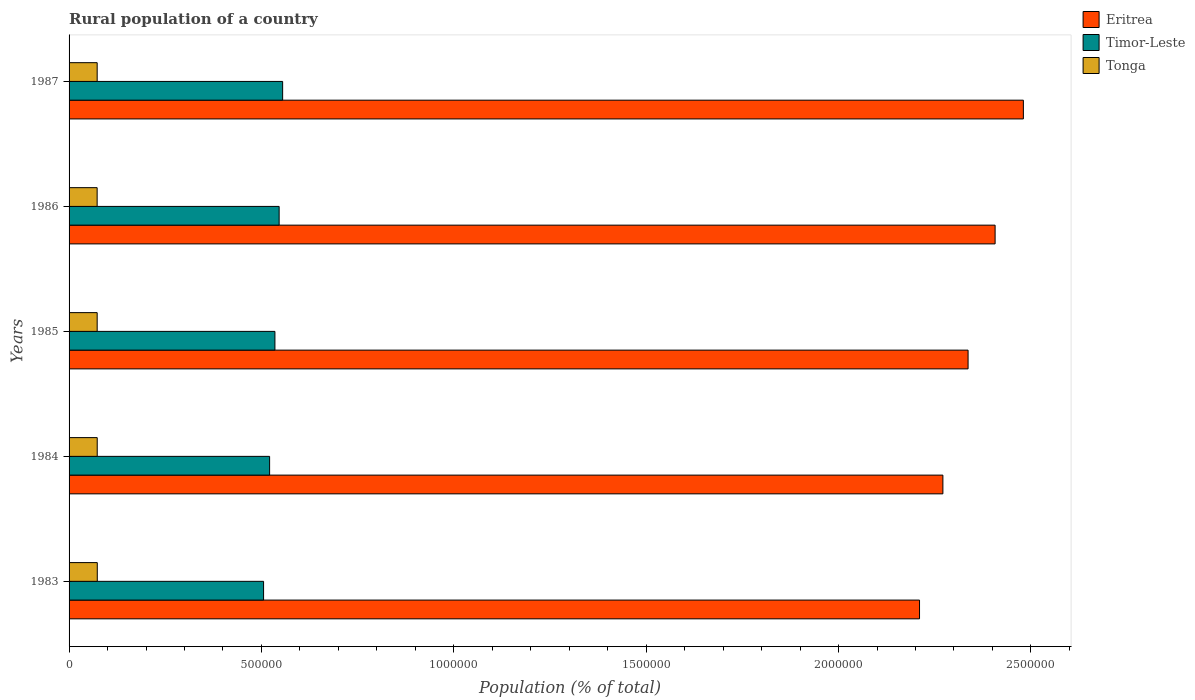How many groups of bars are there?
Your answer should be very brief. 5. How many bars are there on the 5th tick from the bottom?
Your answer should be very brief. 3. What is the rural population in Eritrea in 1987?
Offer a very short reply. 2.48e+06. Across all years, what is the maximum rural population in Timor-Leste?
Your response must be concise. 5.55e+05. Across all years, what is the minimum rural population in Tonga?
Offer a terse response. 7.30e+04. In which year was the rural population in Tonga maximum?
Make the answer very short. 1983. What is the total rural population in Eritrea in the graph?
Offer a very short reply. 1.17e+07. What is the difference between the rural population in Eritrea in 1983 and that in 1984?
Provide a succinct answer. -6.07e+04. What is the difference between the rural population in Tonga in 1986 and the rural population in Timor-Leste in 1984?
Your answer should be very brief. -4.48e+05. What is the average rural population in Tonga per year?
Provide a short and direct response. 7.31e+04. In the year 1984, what is the difference between the rural population in Timor-Leste and rural population in Tonga?
Your answer should be very brief. 4.48e+05. What is the ratio of the rural population in Eritrea in 1983 to that in 1987?
Keep it short and to the point. 0.89. What is the difference between the highest and the second highest rural population in Timor-Leste?
Your answer should be compact. 9097. What is the difference between the highest and the lowest rural population in Eritrea?
Your response must be concise. 2.70e+05. In how many years, is the rural population in Eritrea greater than the average rural population in Eritrea taken over all years?
Provide a short and direct response. 2. What does the 1st bar from the top in 1985 represents?
Provide a succinct answer. Tonga. What does the 3rd bar from the bottom in 1983 represents?
Provide a short and direct response. Tonga. Is it the case that in every year, the sum of the rural population in Tonga and rural population in Eritrea is greater than the rural population in Timor-Leste?
Provide a succinct answer. Yes. How many years are there in the graph?
Offer a very short reply. 5. Are the values on the major ticks of X-axis written in scientific E-notation?
Provide a short and direct response. No. Does the graph contain grids?
Provide a succinct answer. No. How many legend labels are there?
Provide a succinct answer. 3. What is the title of the graph?
Your answer should be compact. Rural population of a country. What is the label or title of the X-axis?
Provide a short and direct response. Population (% of total). What is the Population (% of total) in Eritrea in 1983?
Offer a terse response. 2.21e+06. What is the Population (% of total) of Timor-Leste in 1983?
Provide a succinct answer. 5.06e+05. What is the Population (% of total) of Tonga in 1983?
Keep it short and to the point. 7.33e+04. What is the Population (% of total) of Eritrea in 1984?
Provide a short and direct response. 2.27e+06. What is the Population (% of total) of Timor-Leste in 1984?
Offer a very short reply. 5.21e+05. What is the Population (% of total) in Tonga in 1984?
Your answer should be very brief. 7.32e+04. What is the Population (% of total) in Eritrea in 1985?
Ensure brevity in your answer.  2.34e+06. What is the Population (% of total) of Timor-Leste in 1985?
Your answer should be compact. 5.35e+05. What is the Population (% of total) of Tonga in 1985?
Give a very brief answer. 7.30e+04. What is the Population (% of total) of Eritrea in 1986?
Make the answer very short. 2.41e+06. What is the Population (% of total) in Timor-Leste in 1986?
Your answer should be very brief. 5.46e+05. What is the Population (% of total) of Tonga in 1986?
Make the answer very short. 7.30e+04. What is the Population (% of total) in Eritrea in 1987?
Offer a terse response. 2.48e+06. What is the Population (% of total) in Timor-Leste in 1987?
Give a very brief answer. 5.55e+05. What is the Population (% of total) in Tonga in 1987?
Ensure brevity in your answer.  7.31e+04. Across all years, what is the maximum Population (% of total) in Eritrea?
Your response must be concise. 2.48e+06. Across all years, what is the maximum Population (% of total) of Timor-Leste?
Keep it short and to the point. 5.55e+05. Across all years, what is the maximum Population (% of total) in Tonga?
Ensure brevity in your answer.  7.33e+04. Across all years, what is the minimum Population (% of total) in Eritrea?
Offer a terse response. 2.21e+06. Across all years, what is the minimum Population (% of total) in Timor-Leste?
Provide a short and direct response. 5.06e+05. Across all years, what is the minimum Population (% of total) in Tonga?
Offer a terse response. 7.30e+04. What is the total Population (% of total) in Eritrea in the graph?
Make the answer very short. 1.17e+07. What is the total Population (% of total) of Timor-Leste in the graph?
Offer a terse response. 2.66e+06. What is the total Population (% of total) in Tonga in the graph?
Ensure brevity in your answer.  3.66e+05. What is the difference between the Population (% of total) in Eritrea in 1983 and that in 1984?
Give a very brief answer. -6.07e+04. What is the difference between the Population (% of total) of Timor-Leste in 1983 and that in 1984?
Make the answer very short. -1.56e+04. What is the difference between the Population (% of total) in Tonga in 1983 and that in 1984?
Offer a terse response. 162. What is the difference between the Population (% of total) of Eritrea in 1983 and that in 1985?
Your answer should be compact. -1.26e+05. What is the difference between the Population (% of total) of Timor-Leste in 1983 and that in 1985?
Keep it short and to the point. -2.95e+04. What is the difference between the Population (% of total) of Tonga in 1983 and that in 1985?
Your answer should be compact. 284. What is the difference between the Population (% of total) of Eritrea in 1983 and that in 1986?
Provide a short and direct response. -1.96e+05. What is the difference between the Population (% of total) of Timor-Leste in 1983 and that in 1986?
Ensure brevity in your answer.  -4.04e+04. What is the difference between the Population (% of total) of Tonga in 1983 and that in 1986?
Your answer should be very brief. 348. What is the difference between the Population (% of total) of Eritrea in 1983 and that in 1987?
Keep it short and to the point. -2.70e+05. What is the difference between the Population (% of total) in Timor-Leste in 1983 and that in 1987?
Provide a short and direct response. -4.95e+04. What is the difference between the Population (% of total) in Tonga in 1983 and that in 1987?
Your answer should be compact. 260. What is the difference between the Population (% of total) in Eritrea in 1984 and that in 1985?
Make the answer very short. -6.55e+04. What is the difference between the Population (% of total) in Timor-Leste in 1984 and that in 1985?
Your answer should be compact. -1.38e+04. What is the difference between the Population (% of total) of Tonga in 1984 and that in 1985?
Ensure brevity in your answer.  122. What is the difference between the Population (% of total) in Eritrea in 1984 and that in 1986?
Make the answer very short. -1.36e+05. What is the difference between the Population (% of total) in Timor-Leste in 1984 and that in 1986?
Your answer should be compact. -2.48e+04. What is the difference between the Population (% of total) in Tonga in 1984 and that in 1986?
Give a very brief answer. 186. What is the difference between the Population (% of total) in Eritrea in 1984 and that in 1987?
Provide a short and direct response. -2.09e+05. What is the difference between the Population (% of total) of Timor-Leste in 1984 and that in 1987?
Offer a very short reply. -3.39e+04. What is the difference between the Population (% of total) of Tonga in 1984 and that in 1987?
Ensure brevity in your answer.  98. What is the difference between the Population (% of total) in Eritrea in 1985 and that in 1986?
Your answer should be very brief. -7.02e+04. What is the difference between the Population (% of total) in Timor-Leste in 1985 and that in 1986?
Ensure brevity in your answer.  -1.10e+04. What is the difference between the Population (% of total) of Tonga in 1985 and that in 1986?
Make the answer very short. 64. What is the difference between the Population (% of total) of Eritrea in 1985 and that in 1987?
Offer a terse response. -1.44e+05. What is the difference between the Population (% of total) in Timor-Leste in 1985 and that in 1987?
Ensure brevity in your answer.  -2.01e+04. What is the difference between the Population (% of total) in Eritrea in 1986 and that in 1987?
Keep it short and to the point. -7.35e+04. What is the difference between the Population (% of total) of Timor-Leste in 1986 and that in 1987?
Your response must be concise. -9097. What is the difference between the Population (% of total) in Tonga in 1986 and that in 1987?
Give a very brief answer. -88. What is the difference between the Population (% of total) of Eritrea in 1983 and the Population (% of total) of Timor-Leste in 1984?
Ensure brevity in your answer.  1.69e+06. What is the difference between the Population (% of total) of Eritrea in 1983 and the Population (% of total) of Tonga in 1984?
Give a very brief answer. 2.14e+06. What is the difference between the Population (% of total) of Timor-Leste in 1983 and the Population (% of total) of Tonga in 1984?
Your response must be concise. 4.32e+05. What is the difference between the Population (% of total) of Eritrea in 1983 and the Population (% of total) of Timor-Leste in 1985?
Offer a very short reply. 1.68e+06. What is the difference between the Population (% of total) in Eritrea in 1983 and the Population (% of total) in Tonga in 1985?
Your answer should be very brief. 2.14e+06. What is the difference between the Population (% of total) in Timor-Leste in 1983 and the Population (% of total) in Tonga in 1985?
Give a very brief answer. 4.33e+05. What is the difference between the Population (% of total) of Eritrea in 1983 and the Population (% of total) of Timor-Leste in 1986?
Your answer should be compact. 1.66e+06. What is the difference between the Population (% of total) of Eritrea in 1983 and the Population (% of total) of Tonga in 1986?
Offer a terse response. 2.14e+06. What is the difference between the Population (% of total) of Timor-Leste in 1983 and the Population (% of total) of Tonga in 1986?
Offer a very short reply. 4.33e+05. What is the difference between the Population (% of total) in Eritrea in 1983 and the Population (% of total) in Timor-Leste in 1987?
Offer a very short reply. 1.66e+06. What is the difference between the Population (% of total) of Eritrea in 1983 and the Population (% of total) of Tonga in 1987?
Provide a short and direct response. 2.14e+06. What is the difference between the Population (% of total) in Timor-Leste in 1983 and the Population (% of total) in Tonga in 1987?
Keep it short and to the point. 4.33e+05. What is the difference between the Population (% of total) of Eritrea in 1984 and the Population (% of total) of Timor-Leste in 1985?
Keep it short and to the point. 1.74e+06. What is the difference between the Population (% of total) in Eritrea in 1984 and the Population (% of total) in Tonga in 1985?
Offer a terse response. 2.20e+06. What is the difference between the Population (% of total) in Timor-Leste in 1984 and the Population (% of total) in Tonga in 1985?
Provide a succinct answer. 4.48e+05. What is the difference between the Population (% of total) of Eritrea in 1984 and the Population (% of total) of Timor-Leste in 1986?
Keep it short and to the point. 1.73e+06. What is the difference between the Population (% of total) in Eritrea in 1984 and the Population (% of total) in Tonga in 1986?
Provide a succinct answer. 2.20e+06. What is the difference between the Population (% of total) in Timor-Leste in 1984 and the Population (% of total) in Tonga in 1986?
Keep it short and to the point. 4.48e+05. What is the difference between the Population (% of total) of Eritrea in 1984 and the Population (% of total) of Timor-Leste in 1987?
Keep it short and to the point. 1.72e+06. What is the difference between the Population (% of total) of Eritrea in 1984 and the Population (% of total) of Tonga in 1987?
Make the answer very short. 2.20e+06. What is the difference between the Population (% of total) of Timor-Leste in 1984 and the Population (% of total) of Tonga in 1987?
Provide a short and direct response. 4.48e+05. What is the difference between the Population (% of total) of Eritrea in 1985 and the Population (% of total) of Timor-Leste in 1986?
Give a very brief answer. 1.79e+06. What is the difference between the Population (% of total) in Eritrea in 1985 and the Population (% of total) in Tonga in 1986?
Ensure brevity in your answer.  2.26e+06. What is the difference between the Population (% of total) of Timor-Leste in 1985 and the Population (% of total) of Tonga in 1986?
Give a very brief answer. 4.62e+05. What is the difference between the Population (% of total) in Eritrea in 1985 and the Population (% of total) in Timor-Leste in 1987?
Your response must be concise. 1.78e+06. What is the difference between the Population (% of total) in Eritrea in 1985 and the Population (% of total) in Tonga in 1987?
Make the answer very short. 2.26e+06. What is the difference between the Population (% of total) in Timor-Leste in 1985 and the Population (% of total) in Tonga in 1987?
Offer a very short reply. 4.62e+05. What is the difference between the Population (% of total) of Eritrea in 1986 and the Population (% of total) of Timor-Leste in 1987?
Provide a succinct answer. 1.85e+06. What is the difference between the Population (% of total) of Eritrea in 1986 and the Population (% of total) of Tonga in 1987?
Provide a short and direct response. 2.33e+06. What is the difference between the Population (% of total) in Timor-Leste in 1986 and the Population (% of total) in Tonga in 1987?
Provide a short and direct response. 4.73e+05. What is the average Population (% of total) of Eritrea per year?
Offer a very short reply. 2.34e+06. What is the average Population (% of total) of Timor-Leste per year?
Provide a succinct answer. 5.33e+05. What is the average Population (% of total) of Tonga per year?
Offer a very short reply. 7.31e+04. In the year 1983, what is the difference between the Population (% of total) of Eritrea and Population (% of total) of Timor-Leste?
Make the answer very short. 1.70e+06. In the year 1983, what is the difference between the Population (% of total) in Eritrea and Population (% of total) in Tonga?
Ensure brevity in your answer.  2.14e+06. In the year 1983, what is the difference between the Population (% of total) in Timor-Leste and Population (% of total) in Tonga?
Your answer should be very brief. 4.32e+05. In the year 1984, what is the difference between the Population (% of total) in Eritrea and Population (% of total) in Timor-Leste?
Offer a very short reply. 1.75e+06. In the year 1984, what is the difference between the Population (% of total) of Eritrea and Population (% of total) of Tonga?
Keep it short and to the point. 2.20e+06. In the year 1984, what is the difference between the Population (% of total) in Timor-Leste and Population (% of total) in Tonga?
Offer a very short reply. 4.48e+05. In the year 1985, what is the difference between the Population (% of total) of Eritrea and Population (% of total) of Timor-Leste?
Provide a short and direct response. 1.80e+06. In the year 1985, what is the difference between the Population (% of total) in Eritrea and Population (% of total) in Tonga?
Provide a short and direct response. 2.26e+06. In the year 1985, what is the difference between the Population (% of total) in Timor-Leste and Population (% of total) in Tonga?
Your answer should be very brief. 4.62e+05. In the year 1986, what is the difference between the Population (% of total) in Eritrea and Population (% of total) in Timor-Leste?
Your answer should be very brief. 1.86e+06. In the year 1986, what is the difference between the Population (% of total) of Eritrea and Population (% of total) of Tonga?
Keep it short and to the point. 2.33e+06. In the year 1986, what is the difference between the Population (% of total) in Timor-Leste and Population (% of total) in Tonga?
Give a very brief answer. 4.73e+05. In the year 1987, what is the difference between the Population (% of total) in Eritrea and Population (% of total) in Timor-Leste?
Keep it short and to the point. 1.93e+06. In the year 1987, what is the difference between the Population (% of total) in Eritrea and Population (% of total) in Tonga?
Make the answer very short. 2.41e+06. In the year 1987, what is the difference between the Population (% of total) in Timor-Leste and Population (% of total) in Tonga?
Offer a very short reply. 4.82e+05. What is the ratio of the Population (% of total) of Eritrea in 1983 to that in 1984?
Make the answer very short. 0.97. What is the ratio of the Population (% of total) in Timor-Leste in 1983 to that in 1984?
Offer a very short reply. 0.97. What is the ratio of the Population (% of total) of Eritrea in 1983 to that in 1985?
Your answer should be very brief. 0.95. What is the ratio of the Population (% of total) of Timor-Leste in 1983 to that in 1985?
Offer a terse response. 0.94. What is the ratio of the Population (% of total) of Tonga in 1983 to that in 1985?
Keep it short and to the point. 1. What is the ratio of the Population (% of total) of Eritrea in 1983 to that in 1986?
Your answer should be very brief. 0.92. What is the ratio of the Population (% of total) in Timor-Leste in 1983 to that in 1986?
Offer a terse response. 0.93. What is the ratio of the Population (% of total) of Eritrea in 1983 to that in 1987?
Keep it short and to the point. 0.89. What is the ratio of the Population (% of total) of Timor-Leste in 1983 to that in 1987?
Your answer should be compact. 0.91. What is the ratio of the Population (% of total) in Eritrea in 1984 to that in 1985?
Provide a succinct answer. 0.97. What is the ratio of the Population (% of total) of Timor-Leste in 1984 to that in 1985?
Your answer should be very brief. 0.97. What is the ratio of the Population (% of total) in Eritrea in 1984 to that in 1986?
Your answer should be very brief. 0.94. What is the ratio of the Population (% of total) of Timor-Leste in 1984 to that in 1986?
Make the answer very short. 0.95. What is the ratio of the Population (% of total) in Eritrea in 1984 to that in 1987?
Offer a very short reply. 0.92. What is the ratio of the Population (% of total) of Timor-Leste in 1984 to that in 1987?
Ensure brevity in your answer.  0.94. What is the ratio of the Population (% of total) in Tonga in 1984 to that in 1987?
Your answer should be compact. 1. What is the ratio of the Population (% of total) of Eritrea in 1985 to that in 1986?
Ensure brevity in your answer.  0.97. What is the ratio of the Population (% of total) of Timor-Leste in 1985 to that in 1986?
Provide a succinct answer. 0.98. What is the ratio of the Population (% of total) in Eritrea in 1985 to that in 1987?
Your answer should be compact. 0.94. What is the ratio of the Population (% of total) in Timor-Leste in 1985 to that in 1987?
Your answer should be compact. 0.96. What is the ratio of the Population (% of total) of Eritrea in 1986 to that in 1987?
Your response must be concise. 0.97. What is the ratio of the Population (% of total) of Timor-Leste in 1986 to that in 1987?
Your answer should be very brief. 0.98. What is the difference between the highest and the second highest Population (% of total) of Eritrea?
Your answer should be compact. 7.35e+04. What is the difference between the highest and the second highest Population (% of total) of Timor-Leste?
Keep it short and to the point. 9097. What is the difference between the highest and the second highest Population (% of total) of Tonga?
Provide a succinct answer. 162. What is the difference between the highest and the lowest Population (% of total) of Eritrea?
Keep it short and to the point. 2.70e+05. What is the difference between the highest and the lowest Population (% of total) of Timor-Leste?
Make the answer very short. 4.95e+04. What is the difference between the highest and the lowest Population (% of total) in Tonga?
Offer a terse response. 348. 